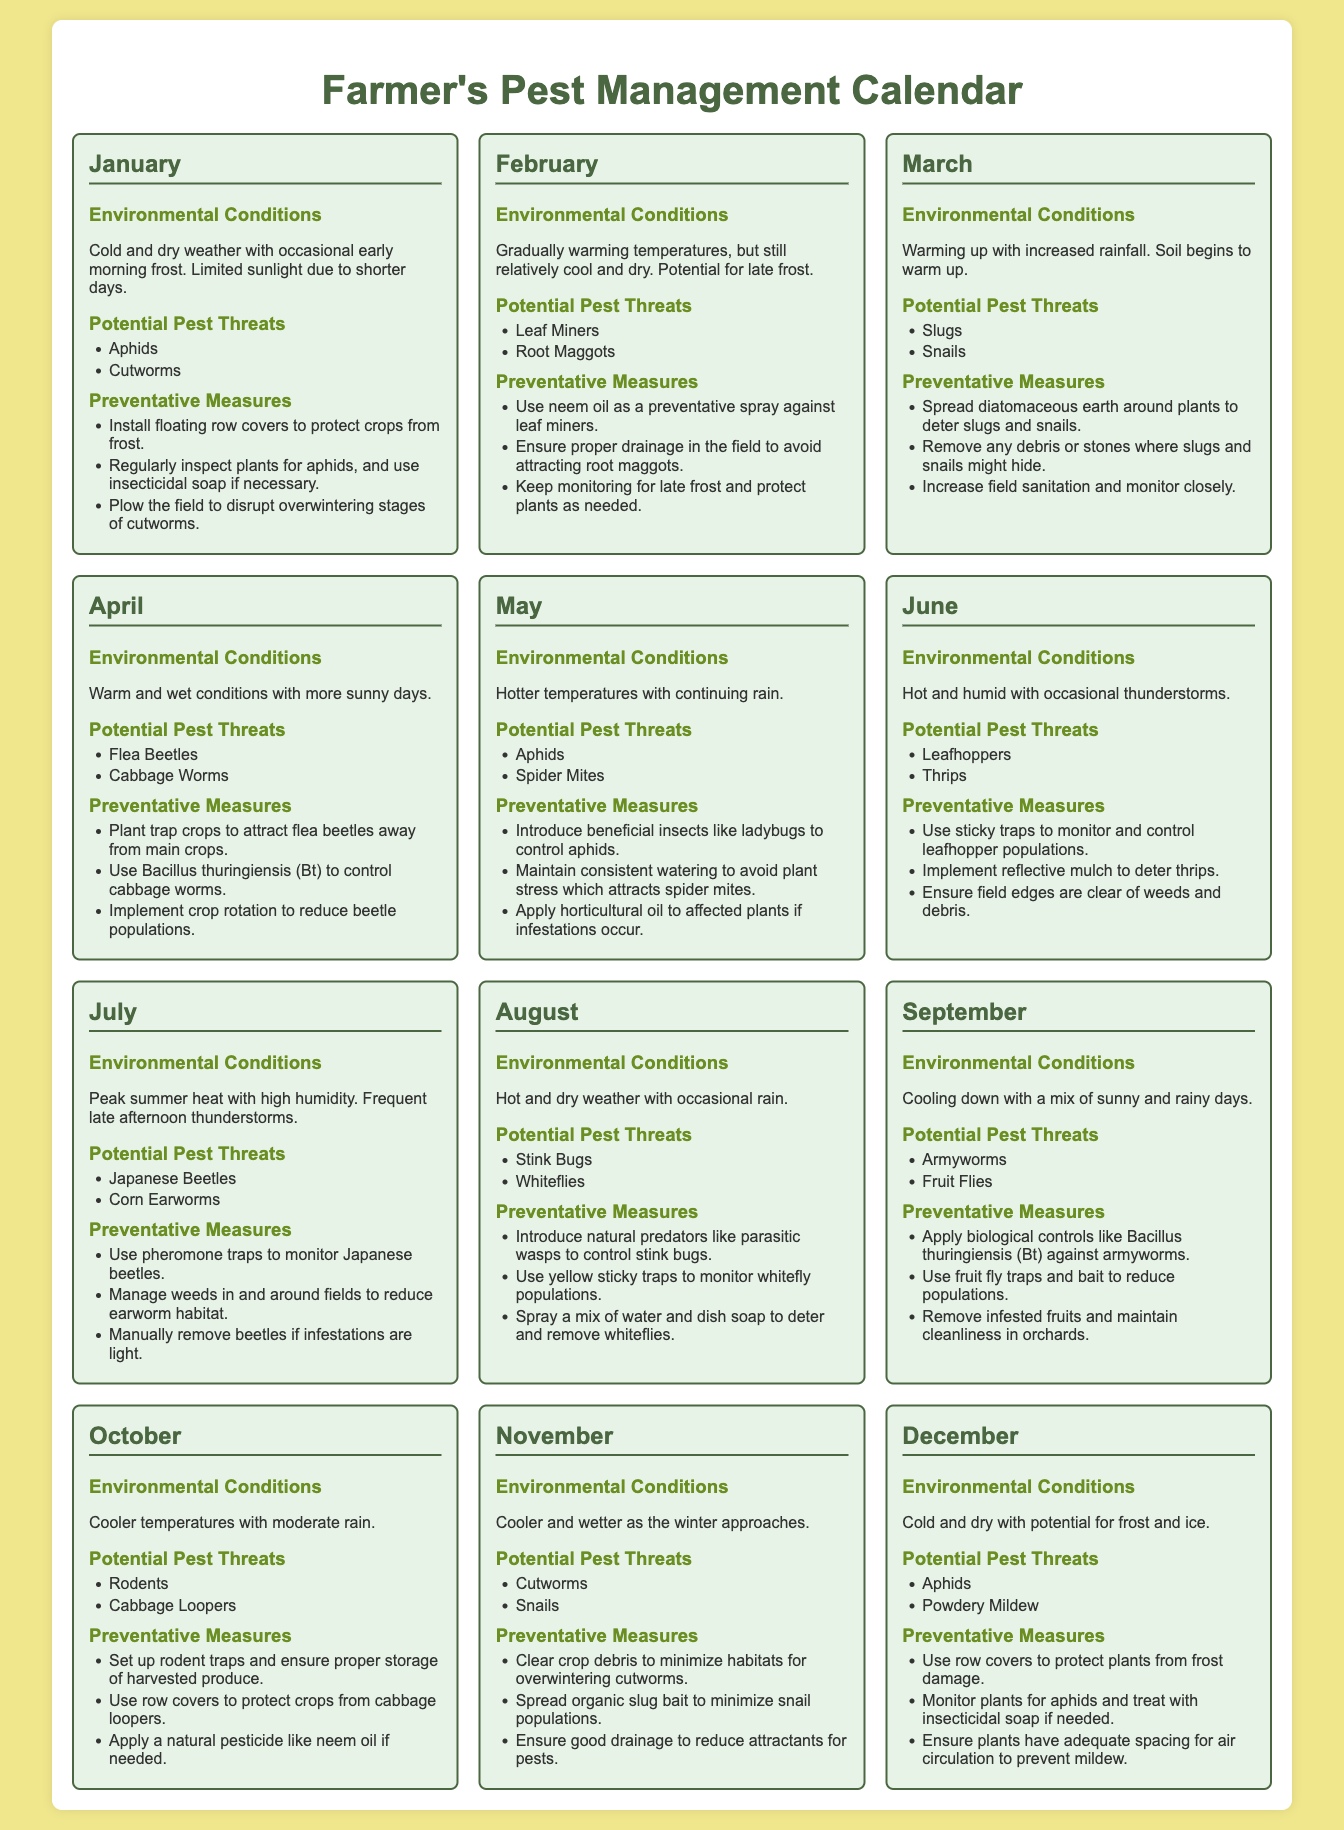What pests are a threat in January? January lists potential pest threats, including aphids and cutworms.
Answer: Aphids, Cutworms What preventative measure is suggested for February? The calendar recommends using neem oil as a preventative spray against leaf miners in February.
Answer: Use neem oil What are the environmental conditions in June? June's environmental conditions are described as hot and humid with occasional thunderstorms.
Answer: Hot and humid How many months mention aphids as a potential pest threat? The months that mention aphids are January, May, and December, which totals three months.
Answer: Three What is the recommended action to control Japanese beetles in July? In July, the recommended action is to use pheromone traps to monitor Japanese beetles.
Answer: Use pheromone traps Which month is characterized by cooler temperatures and moderate rain? October is the month that is described as having cooler temperatures with moderate rain.
Answer: October What are common environmental conditions in August? August is characterized by hot and dry weather with occasional rain.
Answer: Hot and dry Which pests are mentioned for November? November mentions potential pest threats including cutworms and snails.
Answer: Cutworms, Snails 